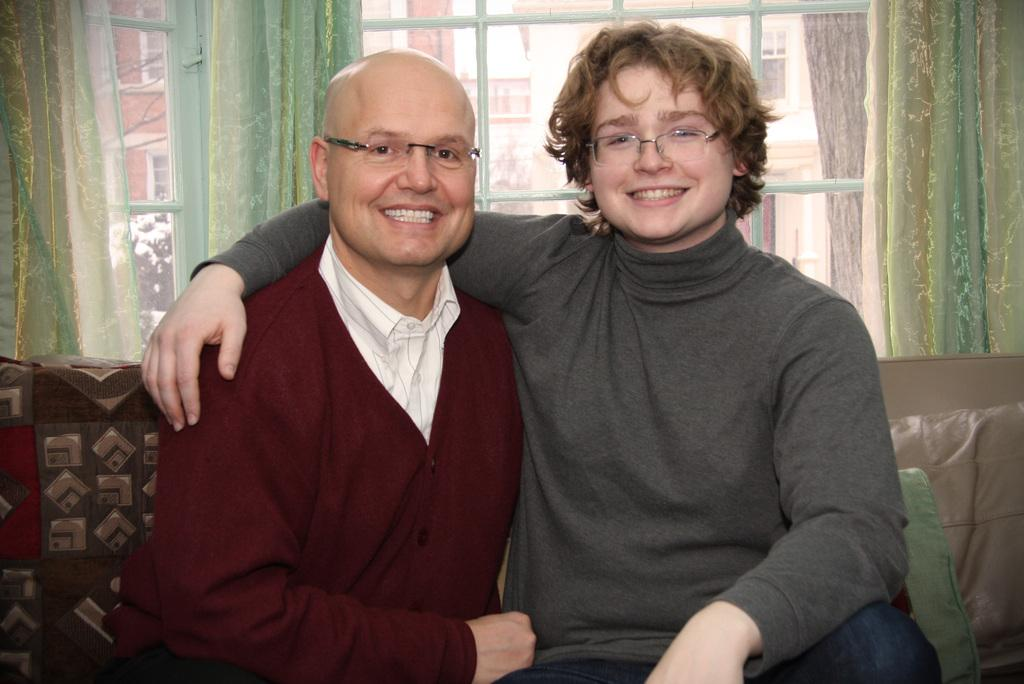How many people are in the image? There are two persons in the image. What are the persons doing in the image? The persons are sitting on a sofa. What can be seen on the faces of the persons? The persons are wearing spectacles. What is visible in the background of the image? There is a window in the background, and trees and buildings are visible from the window. What type of doctor is treating the persons in the image? There is no doctor present in the image; the persons are sitting on a sofa and wearing spectacles. What is the persons' belief about the smashing of the window in the image? There is no mention of a smashed window or any beliefs in the image. 